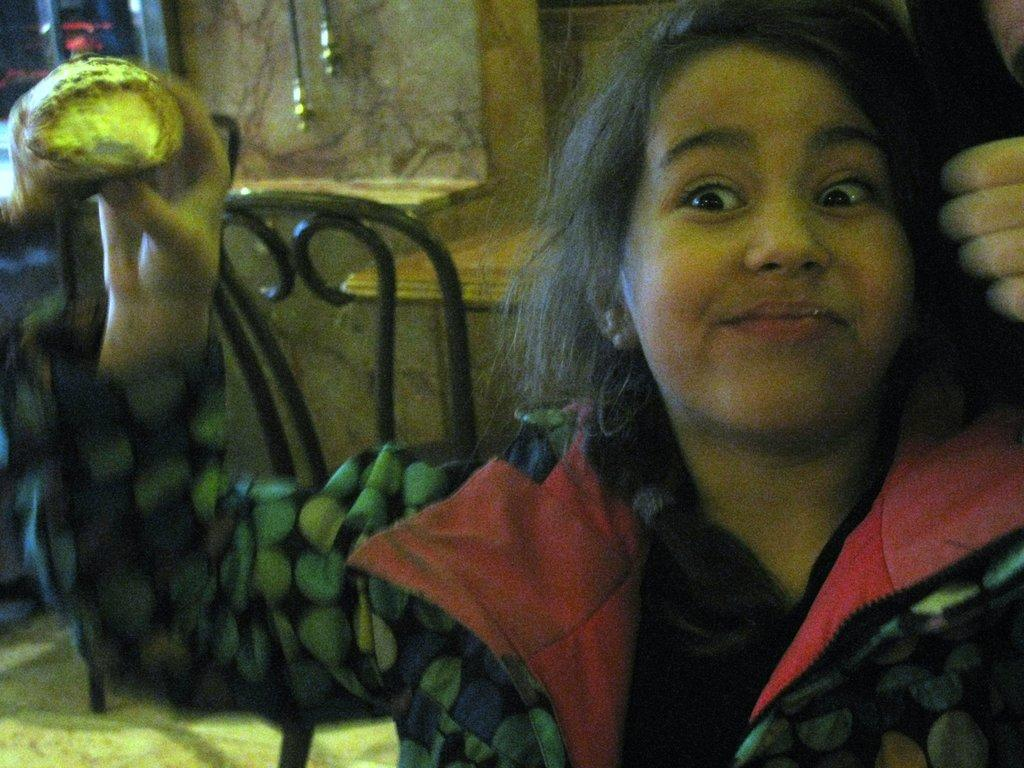Who is the main subject in the image? There is a lady in the image. What is the lady holding in her hand? The lady is holding an object in her hand. What is behind the lady in the image? There is a chair behind the lady. What can be seen in the background of the image? There is a wall visible in the image. How many beggars are visible in the image? There are no beggars visible in the image; it features a lady holding an object and a chair in the background. What type of men can be seen on top of the wall in the image? There are no men visible on top of the wall in the image; it only shows a lady, an object, a chair, and a wall. 